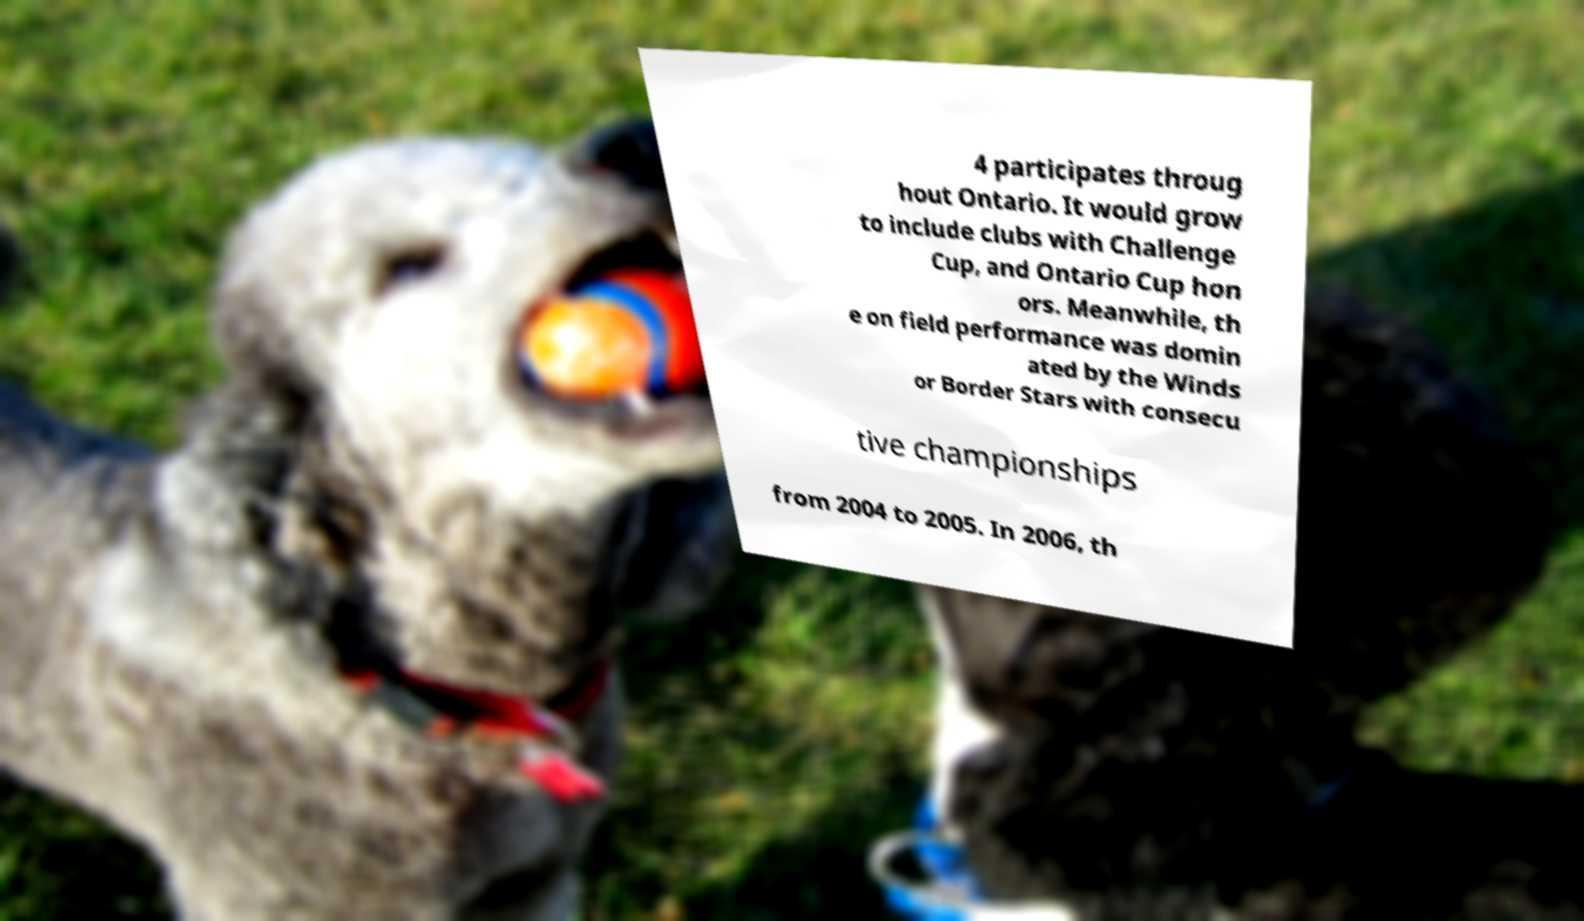Could you extract and type out the text from this image? 4 participates throug hout Ontario. It would grow to include clubs with Challenge Cup, and Ontario Cup hon ors. Meanwhile, th e on field performance was domin ated by the Winds or Border Stars with consecu tive championships from 2004 to 2005. In 2006, th 